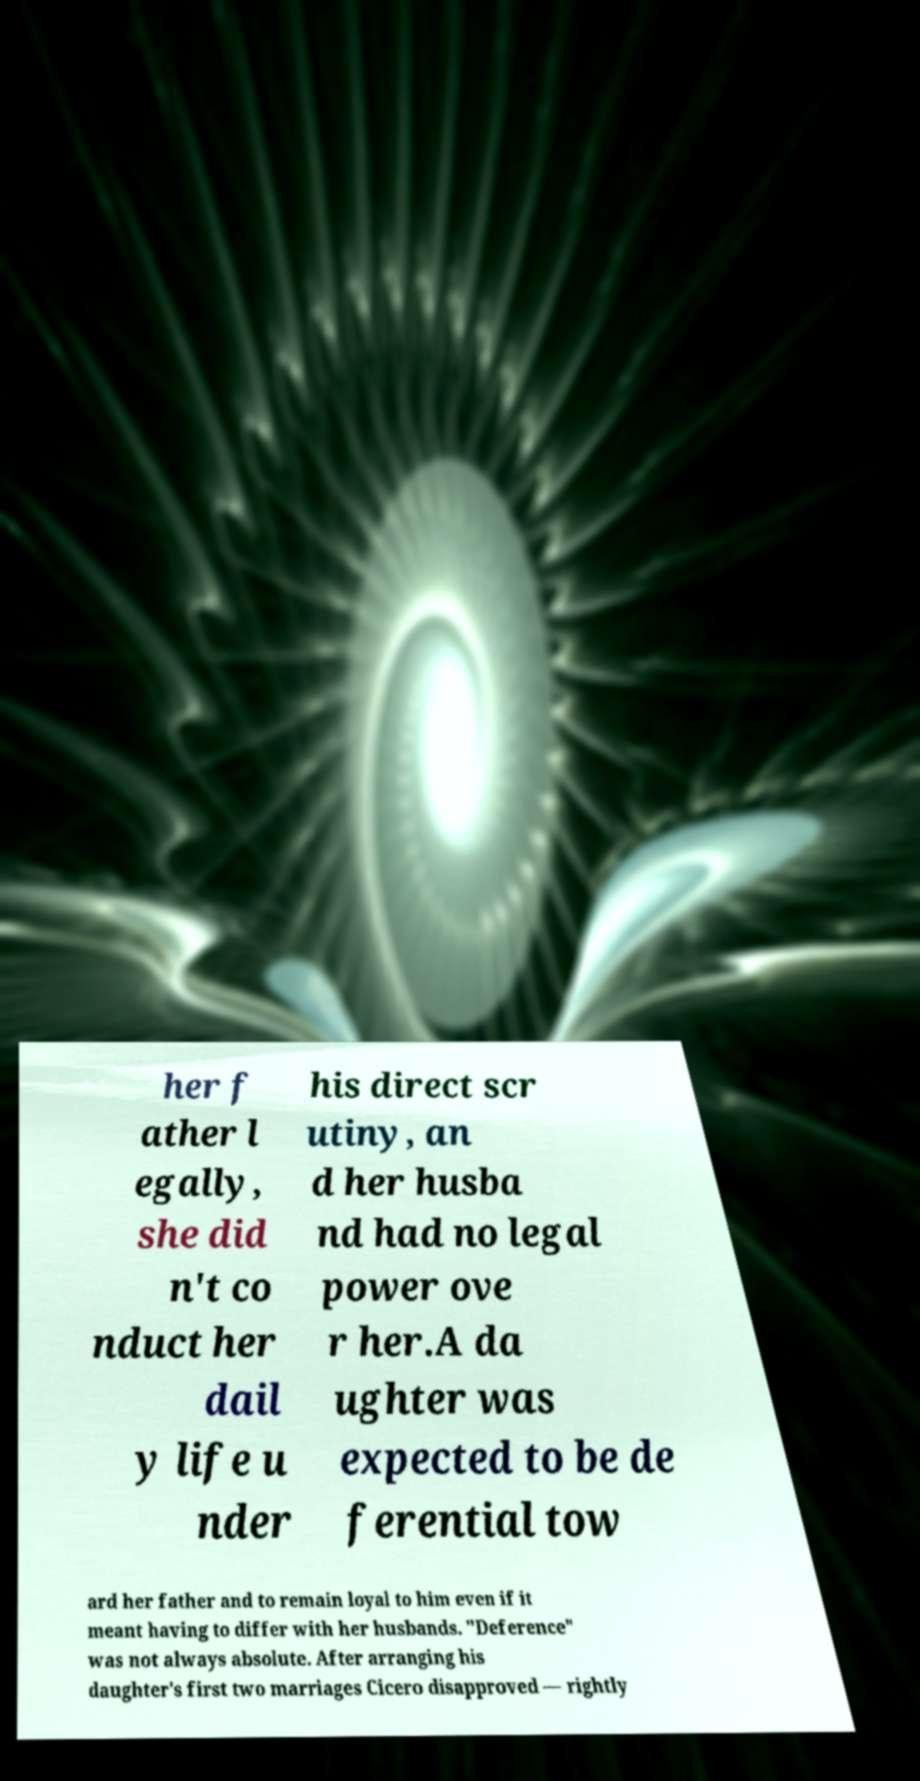Please identify and transcribe the text found in this image. her f ather l egally, she did n't co nduct her dail y life u nder his direct scr utiny, an d her husba nd had no legal power ove r her.A da ughter was expected to be de ferential tow ard her father and to remain loyal to him even if it meant having to differ with her husbands. "Deference" was not always absolute. After arranging his daughter's first two marriages Cicero disapproved — rightly 